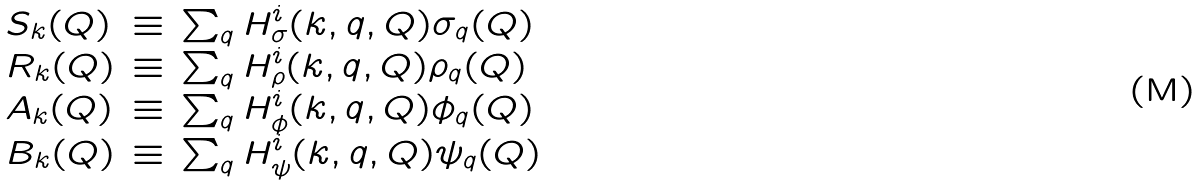<formula> <loc_0><loc_0><loc_500><loc_500>\begin{array} { l l l } { S } _ { k } ( Q ) & \equiv & \sum _ { q } H ^ { i } _ { \sigma } ( k , q , Q ) \sigma _ { q } ( Q ) \\ { R } _ { k } ( Q ) & \equiv & \sum _ { q } H ^ { i } _ { \rho } ( k , q , Q ) \rho _ { q } ( Q ) \\ { A } _ { k } ( Q ) & \equiv & \sum _ { q } H ^ { i } _ { \phi } ( k , q , Q ) \phi _ { q } ( Q ) \\ { B } _ { k } ( Q ) & \equiv & \sum _ { q } H ^ { i } _ { \psi } ( k , q , Q ) \psi _ { q } ( Q ) \\ \end{array}</formula> 